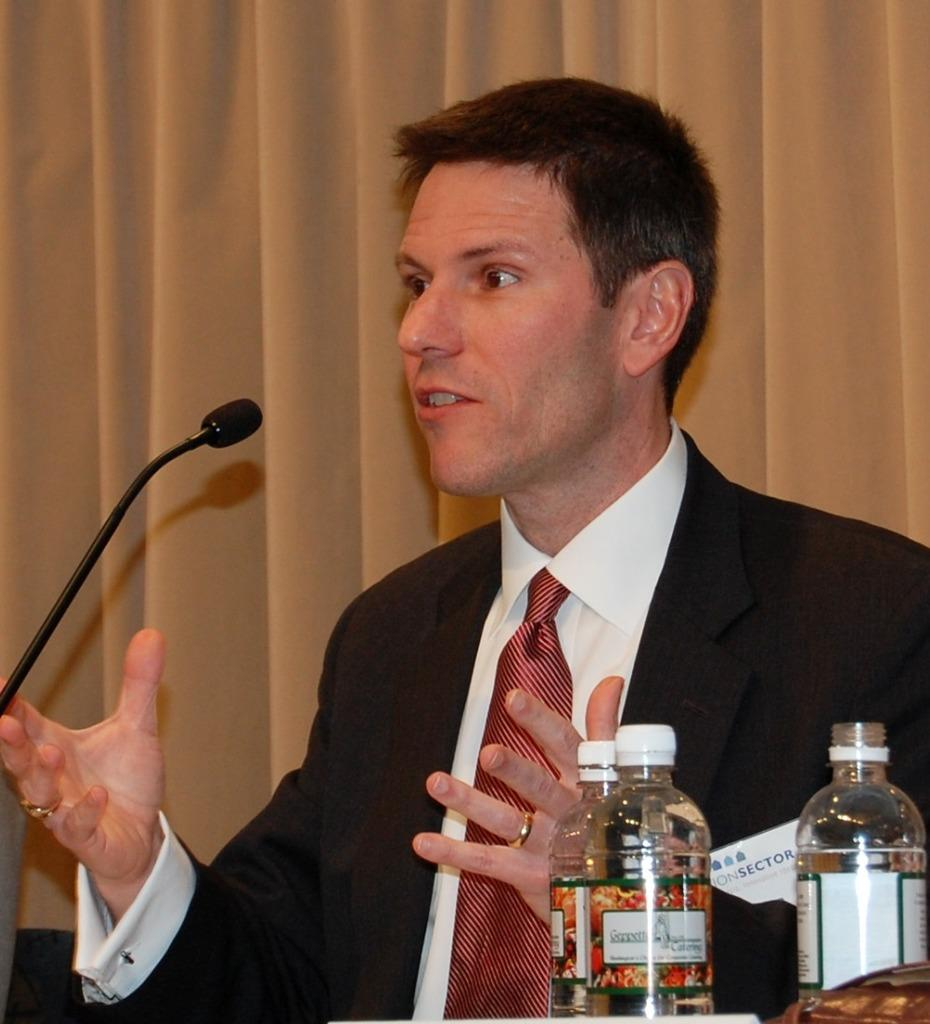What is the man in the image doing? The man is speaking in front of a microphone. What part of the man's body is visible in the image? The man's mouth is visible. What might the man be using to stay hydrated while speaking? There are water bottles in front of the man. What can be seen in the background of the image? There is a curtain in the background of the image. What type of sock is the man wearing in the image? There is no sock visible in the image, as the man is wearing shoes. What is the man using to rake leaves in the image? There is no rake present in the image; the man is speaking in front of a microphone. 